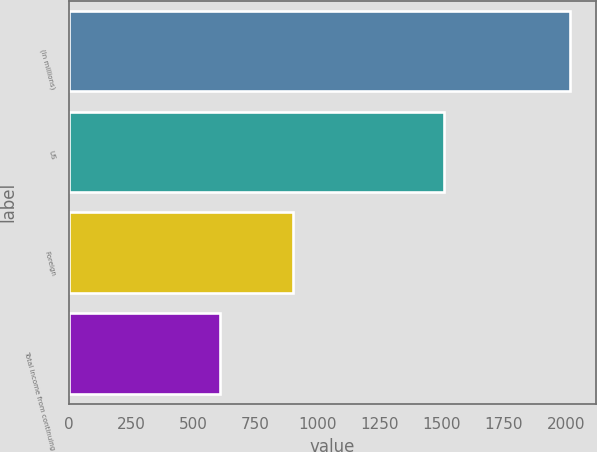<chart> <loc_0><loc_0><loc_500><loc_500><bar_chart><fcel>(In millions)<fcel>US<fcel>Foreign<fcel>Total income from continuing<nl><fcel>2019<fcel>1512<fcel>902<fcel>610<nl></chart> 